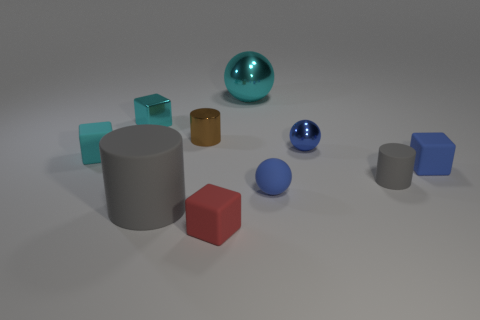Subtract all balls. How many objects are left? 7 Subtract all spheres. Subtract all large spheres. How many objects are left? 6 Add 2 cyan metal blocks. How many cyan metal blocks are left? 3 Add 7 green cubes. How many green cubes exist? 7 Subtract 1 red blocks. How many objects are left? 9 